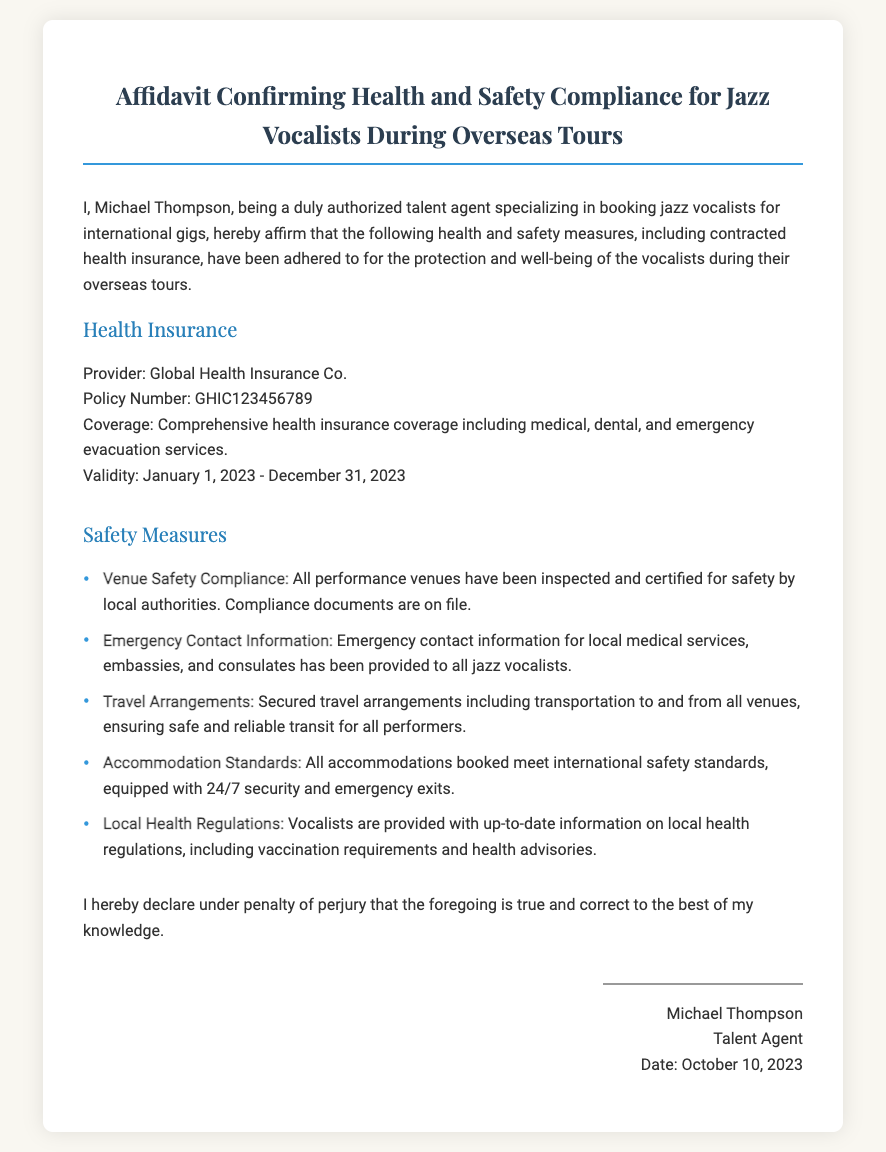what is the name of the health insurance provider? The health insurance provider is stated in the "Health Insurance" section of the document.
Answer: Global Health Insurance Co what is the policy number for the health insurance? The policy number is specifically mentioned in the "Health Insurance" section of the document.
Answer: GHIC123456789 what are the coverage details of the health insurance? The coverage details can be found in the "Health Insurance" section, outlining the specific types of coverage included.
Answer: Comprehensive health insurance coverage including medical, dental, and emergency evacuation services what is the validity period of the health insurance? The validity period is explicitly mentioned in the "Health Insurance" section of the document.
Answer: January 1, 2023 - December 31, 2023 how many safety measures are outlined in the affidavit? The number of safety measures can be counted from the list provided in the "Safety Measures" section.
Answer: Five which safety measure includes local medical services? The "Emergency Contact Information" safety measure specifically mentions local medical services.
Answer: Emergency Contact Information who signed the affidavit? The name of the individual who signed the affidavit is provided at the end in the signature section.
Answer: Michael Thompson when was the affidavit signed? The date of signing is provided in the signature section of the document.
Answer: October 10, 2023 what type of document is this? The document type is defined by the title at the beginning of the document.
Answer: Affidavit Confirming Health and Safety Compliance for Jazz Vocalists During Overseas Tours 